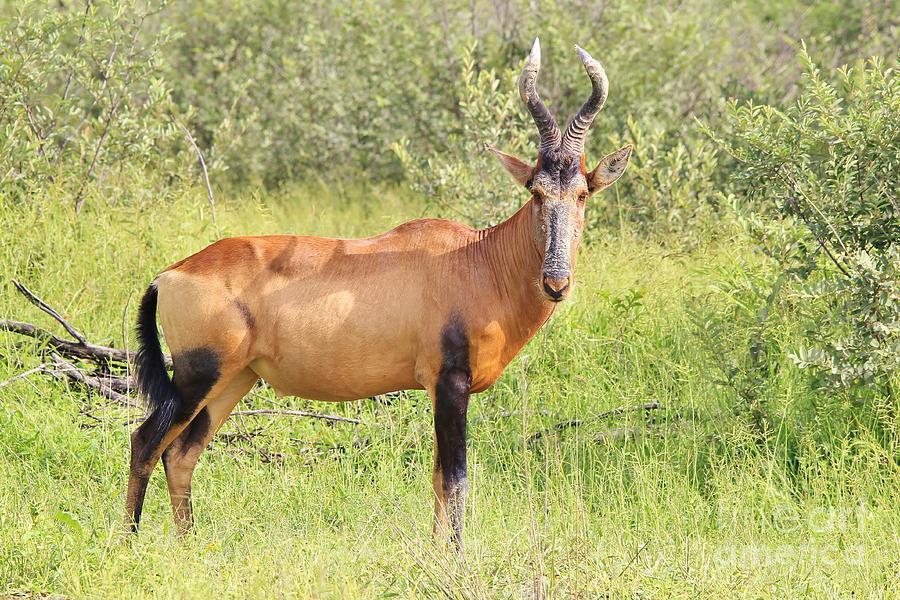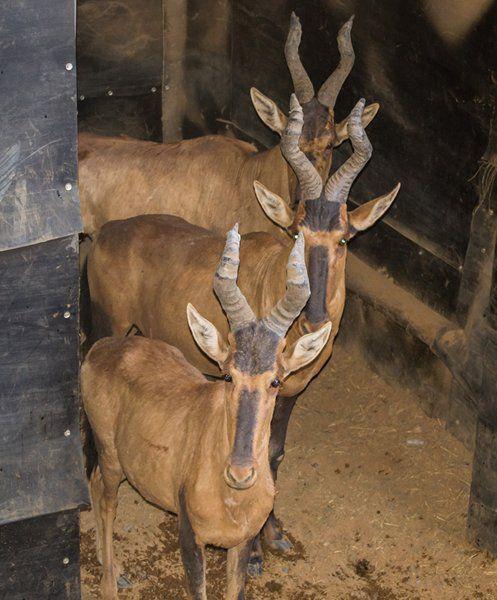The first image is the image on the left, the second image is the image on the right. Considering the images on both sides, is "Each image contains one horned animal, and the animals on the left and right have their heads turned in the same direction." valid? Answer yes or no. No. The first image is the image on the left, the second image is the image on the right. Considering the images on both sides, is "The left and right image contains the same number of standing elk." valid? Answer yes or no. No. 